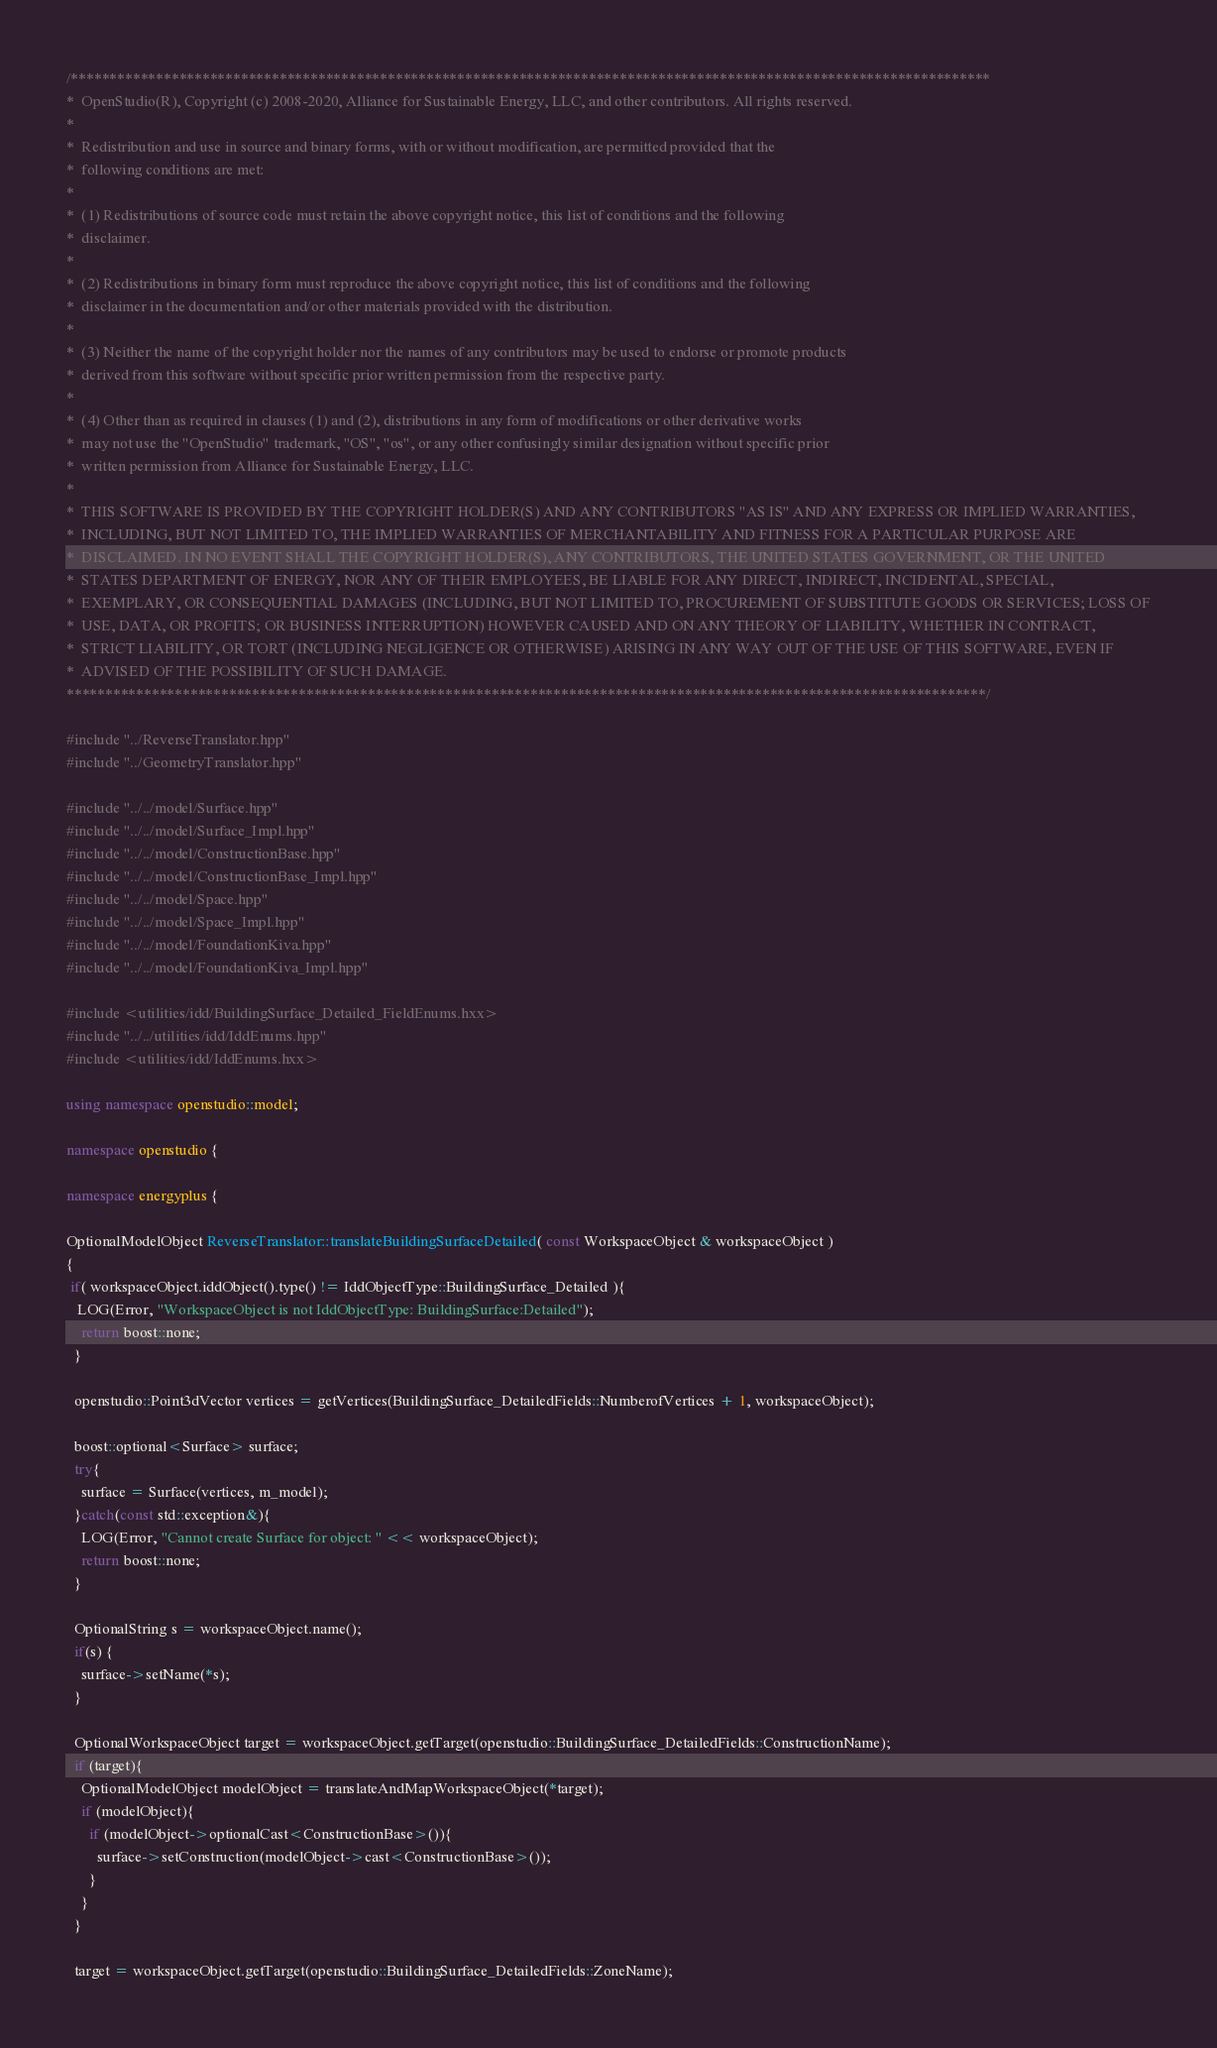<code> <loc_0><loc_0><loc_500><loc_500><_C++_>/***********************************************************************************************************************
*  OpenStudio(R), Copyright (c) 2008-2020, Alliance for Sustainable Energy, LLC, and other contributors. All rights reserved.
*
*  Redistribution and use in source and binary forms, with or without modification, are permitted provided that the
*  following conditions are met:
*
*  (1) Redistributions of source code must retain the above copyright notice, this list of conditions and the following
*  disclaimer.
*
*  (2) Redistributions in binary form must reproduce the above copyright notice, this list of conditions and the following
*  disclaimer in the documentation and/or other materials provided with the distribution.
*
*  (3) Neither the name of the copyright holder nor the names of any contributors may be used to endorse or promote products
*  derived from this software without specific prior written permission from the respective party.
*
*  (4) Other than as required in clauses (1) and (2), distributions in any form of modifications or other derivative works
*  may not use the "OpenStudio" trademark, "OS", "os", or any other confusingly similar designation without specific prior
*  written permission from Alliance for Sustainable Energy, LLC.
*
*  THIS SOFTWARE IS PROVIDED BY THE COPYRIGHT HOLDER(S) AND ANY CONTRIBUTORS "AS IS" AND ANY EXPRESS OR IMPLIED WARRANTIES,
*  INCLUDING, BUT NOT LIMITED TO, THE IMPLIED WARRANTIES OF MERCHANTABILITY AND FITNESS FOR A PARTICULAR PURPOSE ARE
*  DISCLAIMED. IN NO EVENT SHALL THE COPYRIGHT HOLDER(S), ANY CONTRIBUTORS, THE UNITED STATES GOVERNMENT, OR THE UNITED
*  STATES DEPARTMENT OF ENERGY, NOR ANY OF THEIR EMPLOYEES, BE LIABLE FOR ANY DIRECT, INDIRECT, INCIDENTAL, SPECIAL,
*  EXEMPLARY, OR CONSEQUENTIAL DAMAGES (INCLUDING, BUT NOT LIMITED TO, PROCUREMENT OF SUBSTITUTE GOODS OR SERVICES; LOSS OF
*  USE, DATA, OR PROFITS; OR BUSINESS INTERRUPTION) HOWEVER CAUSED AND ON ANY THEORY OF LIABILITY, WHETHER IN CONTRACT,
*  STRICT LIABILITY, OR TORT (INCLUDING NEGLIGENCE OR OTHERWISE) ARISING IN ANY WAY OUT OF THE USE OF THIS SOFTWARE, EVEN IF
*  ADVISED OF THE POSSIBILITY OF SUCH DAMAGE.
***********************************************************************************************************************/

#include "../ReverseTranslator.hpp"
#include "../GeometryTranslator.hpp"

#include "../../model/Surface.hpp"
#include "../../model/Surface_Impl.hpp"
#include "../../model/ConstructionBase.hpp"
#include "../../model/ConstructionBase_Impl.hpp"
#include "../../model/Space.hpp"
#include "../../model/Space_Impl.hpp"
#include "../../model/FoundationKiva.hpp"
#include "../../model/FoundationKiva_Impl.hpp"

#include <utilities/idd/BuildingSurface_Detailed_FieldEnums.hxx>
#include "../../utilities/idd/IddEnums.hpp"
#include <utilities/idd/IddEnums.hxx>

using namespace openstudio::model;

namespace openstudio {

namespace energyplus {

OptionalModelObject ReverseTranslator::translateBuildingSurfaceDetailed( const WorkspaceObject & workspaceObject )
{
 if( workspaceObject.iddObject().type() != IddObjectType::BuildingSurface_Detailed ){
   LOG(Error, "WorkspaceObject is not IddObjectType: BuildingSurface:Detailed");
    return boost::none;
  }

  openstudio::Point3dVector vertices = getVertices(BuildingSurface_DetailedFields::NumberofVertices + 1, workspaceObject);

  boost::optional<Surface> surface;
  try{
    surface = Surface(vertices, m_model);
  }catch(const std::exception&){
    LOG(Error, "Cannot create Surface for object: " << workspaceObject);
    return boost::none;
  }

  OptionalString s = workspaceObject.name();
  if(s) {
    surface->setName(*s);
  }

  OptionalWorkspaceObject target = workspaceObject.getTarget(openstudio::BuildingSurface_DetailedFields::ConstructionName);
  if (target){
    OptionalModelObject modelObject = translateAndMapWorkspaceObject(*target);
    if (modelObject){
      if (modelObject->optionalCast<ConstructionBase>()){
        surface->setConstruction(modelObject->cast<ConstructionBase>());
      }
    }
  }

  target = workspaceObject.getTarget(openstudio::BuildingSurface_DetailedFields::ZoneName);</code> 